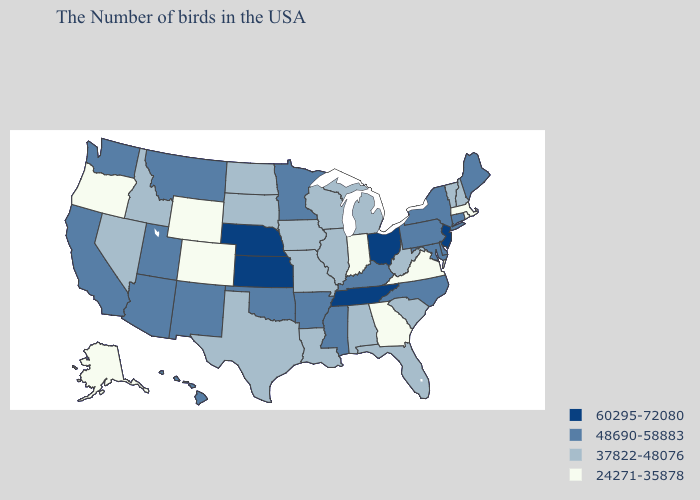Does Connecticut have the lowest value in the Northeast?
Give a very brief answer. No. What is the value of Idaho?
Write a very short answer. 37822-48076. What is the lowest value in the West?
Answer briefly. 24271-35878. Is the legend a continuous bar?
Quick response, please. No. Among the states that border Kentucky , does Tennessee have the lowest value?
Quick response, please. No. What is the lowest value in states that border New Hampshire?
Keep it brief. 24271-35878. What is the value of Vermont?
Give a very brief answer. 37822-48076. What is the highest value in the USA?
Keep it brief. 60295-72080. Does Hawaii have the highest value in the West?
Be succinct. Yes. Name the states that have a value in the range 48690-58883?
Write a very short answer. Maine, Connecticut, New York, Delaware, Maryland, Pennsylvania, North Carolina, Kentucky, Mississippi, Arkansas, Minnesota, Oklahoma, New Mexico, Utah, Montana, Arizona, California, Washington, Hawaii. What is the value of Georgia?
Concise answer only. 24271-35878. Does New Mexico have the highest value in the West?
Write a very short answer. Yes. Does the first symbol in the legend represent the smallest category?
Quick response, please. No. Name the states that have a value in the range 60295-72080?
Concise answer only. New Jersey, Ohio, Tennessee, Kansas, Nebraska. Does Oregon have the lowest value in the West?
Concise answer only. Yes. 